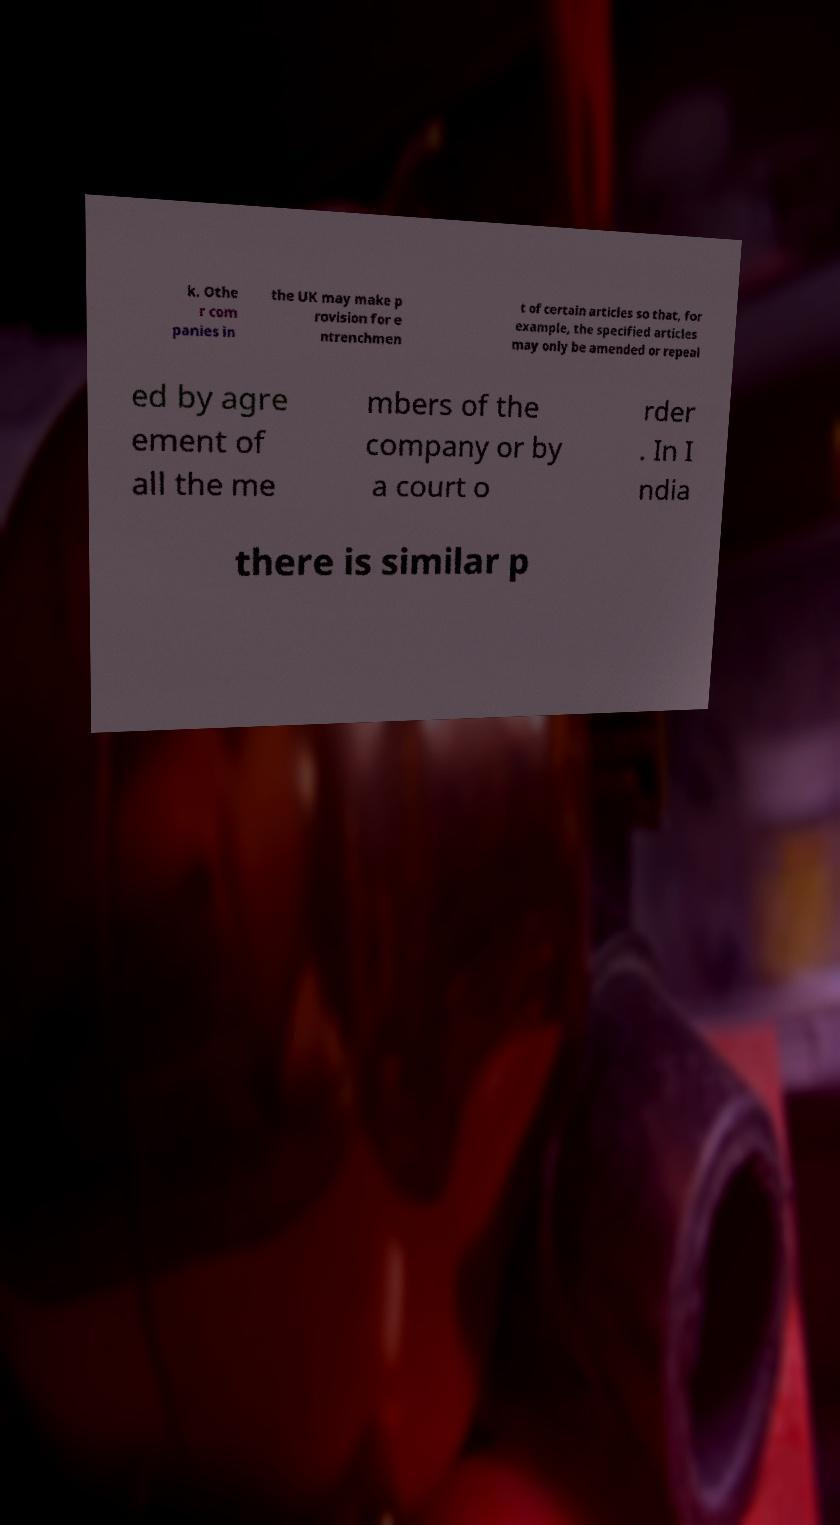There's text embedded in this image that I need extracted. Can you transcribe it verbatim? k. Othe r com panies in the UK may make p rovision for e ntrenchmen t of certain articles so that, for example, the specified articles may only be amended or repeal ed by agre ement of all the me mbers of the company or by a court o rder . In I ndia there is similar p 